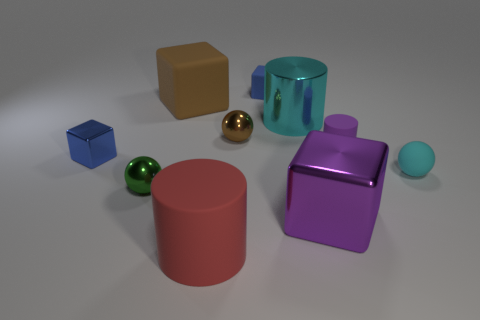How many tiny rubber blocks have the same color as the small metal block?
Ensure brevity in your answer.  1. What color is the small matte thing that is the same shape as the small blue metal thing?
Provide a short and direct response. Blue. There is a large thing that is both in front of the tiny shiny cube and on the right side of the blue rubber thing; what is its shape?
Provide a short and direct response. Cube. Are there more big yellow metal blocks than large red things?
Offer a very short reply. No. What is the big purple thing made of?
Offer a very short reply. Metal. Is there any other thing that has the same size as the red cylinder?
Ensure brevity in your answer.  Yes. What is the size of the green metal thing that is the same shape as the cyan rubber thing?
Make the answer very short. Small. There is a small blue thing that is to the left of the small green ball; are there any red cylinders left of it?
Ensure brevity in your answer.  No. Is the big rubber cylinder the same color as the large metallic cube?
Give a very brief answer. No. What number of other objects are there of the same shape as the cyan metallic object?
Provide a short and direct response. 2. 